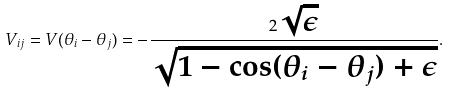<formula> <loc_0><loc_0><loc_500><loc_500>V _ { i j } = V ( \theta _ { i } - \theta _ { j } ) = - \frac { 2 \sqrt { \epsilon } } { \sqrt { 1 - \cos ( \theta _ { i } - \theta _ { j } ) + \epsilon } } .</formula> 